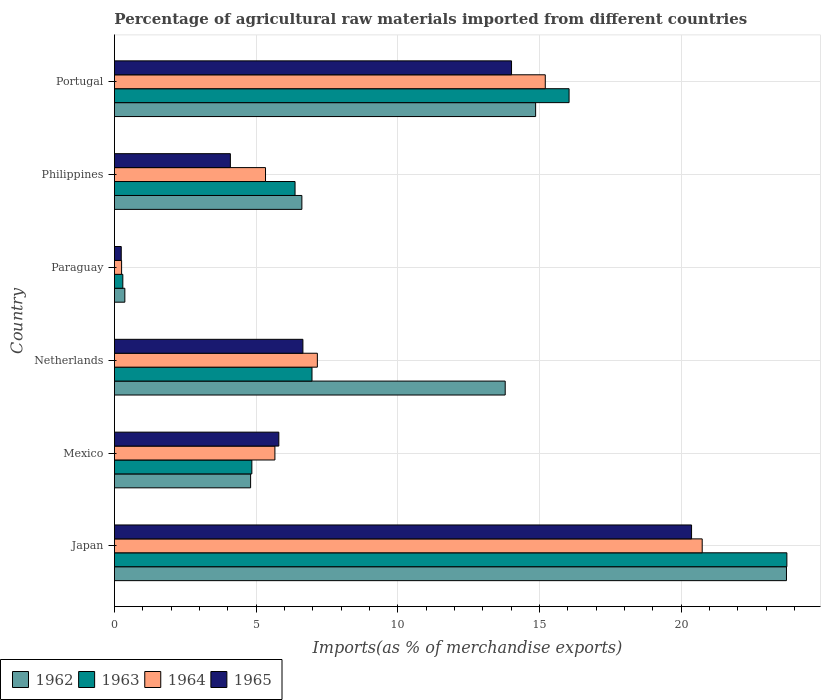How many different coloured bars are there?
Ensure brevity in your answer.  4. Are the number of bars on each tick of the Y-axis equal?
Provide a succinct answer. Yes. How many bars are there on the 5th tick from the bottom?
Make the answer very short. 4. What is the label of the 2nd group of bars from the top?
Offer a terse response. Philippines. What is the percentage of imports to different countries in 1962 in Paraguay?
Give a very brief answer. 0.37. Across all countries, what is the maximum percentage of imports to different countries in 1962?
Give a very brief answer. 23.71. Across all countries, what is the minimum percentage of imports to different countries in 1963?
Your answer should be compact. 0.3. In which country was the percentage of imports to different countries in 1965 minimum?
Your answer should be very brief. Paraguay. What is the total percentage of imports to different countries in 1964 in the graph?
Give a very brief answer. 54.35. What is the difference between the percentage of imports to different countries in 1964 in Japan and that in Portugal?
Your response must be concise. 5.54. What is the difference between the percentage of imports to different countries in 1965 in Japan and the percentage of imports to different countries in 1963 in Netherlands?
Ensure brevity in your answer.  13.39. What is the average percentage of imports to different countries in 1962 per country?
Keep it short and to the point. 10.69. What is the difference between the percentage of imports to different countries in 1965 and percentage of imports to different countries in 1962 in Netherlands?
Provide a short and direct response. -7.14. What is the ratio of the percentage of imports to different countries in 1963 in Netherlands to that in Philippines?
Your response must be concise. 1.09. What is the difference between the highest and the second highest percentage of imports to different countries in 1965?
Provide a short and direct response. 6.35. What is the difference between the highest and the lowest percentage of imports to different countries in 1962?
Offer a terse response. 23.35. In how many countries, is the percentage of imports to different countries in 1963 greater than the average percentage of imports to different countries in 1963 taken over all countries?
Keep it short and to the point. 2. Is the sum of the percentage of imports to different countries in 1962 in Netherlands and Paraguay greater than the maximum percentage of imports to different countries in 1965 across all countries?
Your response must be concise. No. What does the 2nd bar from the top in Philippines represents?
Keep it short and to the point. 1964. What does the 1st bar from the bottom in Philippines represents?
Ensure brevity in your answer.  1962. Are all the bars in the graph horizontal?
Offer a very short reply. Yes. Are the values on the major ticks of X-axis written in scientific E-notation?
Give a very brief answer. No. Does the graph contain any zero values?
Your answer should be compact. No. Does the graph contain grids?
Make the answer very short. Yes. What is the title of the graph?
Provide a succinct answer. Percentage of agricultural raw materials imported from different countries. What is the label or title of the X-axis?
Your response must be concise. Imports(as % of merchandise exports). What is the label or title of the Y-axis?
Keep it short and to the point. Country. What is the Imports(as % of merchandise exports) in 1962 in Japan?
Provide a succinct answer. 23.71. What is the Imports(as % of merchandise exports) in 1963 in Japan?
Keep it short and to the point. 23.73. What is the Imports(as % of merchandise exports) in 1964 in Japan?
Offer a very short reply. 20.74. What is the Imports(as % of merchandise exports) of 1965 in Japan?
Make the answer very short. 20.37. What is the Imports(as % of merchandise exports) in 1962 in Mexico?
Offer a very short reply. 4.81. What is the Imports(as % of merchandise exports) of 1963 in Mexico?
Provide a short and direct response. 4.85. What is the Imports(as % of merchandise exports) in 1964 in Mexico?
Your answer should be very brief. 5.66. What is the Imports(as % of merchandise exports) in 1965 in Mexico?
Your response must be concise. 5.8. What is the Imports(as % of merchandise exports) of 1962 in Netherlands?
Your response must be concise. 13.79. What is the Imports(as % of merchandise exports) in 1963 in Netherlands?
Ensure brevity in your answer.  6.97. What is the Imports(as % of merchandise exports) of 1964 in Netherlands?
Give a very brief answer. 7.16. What is the Imports(as % of merchandise exports) of 1965 in Netherlands?
Give a very brief answer. 6.65. What is the Imports(as % of merchandise exports) in 1962 in Paraguay?
Keep it short and to the point. 0.37. What is the Imports(as % of merchandise exports) in 1963 in Paraguay?
Your response must be concise. 0.3. What is the Imports(as % of merchandise exports) in 1964 in Paraguay?
Your response must be concise. 0.25. What is the Imports(as % of merchandise exports) of 1965 in Paraguay?
Offer a terse response. 0.24. What is the Imports(as % of merchandise exports) of 1962 in Philippines?
Offer a terse response. 6.61. What is the Imports(as % of merchandise exports) in 1963 in Philippines?
Your answer should be compact. 6.37. What is the Imports(as % of merchandise exports) in 1964 in Philippines?
Your answer should be compact. 5.33. What is the Imports(as % of merchandise exports) in 1965 in Philippines?
Make the answer very short. 4.09. What is the Imports(as % of merchandise exports) in 1962 in Portugal?
Ensure brevity in your answer.  14.86. What is the Imports(as % of merchandise exports) in 1963 in Portugal?
Offer a terse response. 16.04. What is the Imports(as % of merchandise exports) of 1964 in Portugal?
Provide a short and direct response. 15.2. What is the Imports(as % of merchandise exports) in 1965 in Portugal?
Your answer should be very brief. 14.01. Across all countries, what is the maximum Imports(as % of merchandise exports) of 1962?
Provide a succinct answer. 23.71. Across all countries, what is the maximum Imports(as % of merchandise exports) of 1963?
Offer a very short reply. 23.73. Across all countries, what is the maximum Imports(as % of merchandise exports) in 1964?
Make the answer very short. 20.74. Across all countries, what is the maximum Imports(as % of merchandise exports) of 1965?
Make the answer very short. 20.37. Across all countries, what is the minimum Imports(as % of merchandise exports) in 1962?
Provide a short and direct response. 0.37. Across all countries, what is the minimum Imports(as % of merchandise exports) in 1963?
Offer a very short reply. 0.3. Across all countries, what is the minimum Imports(as % of merchandise exports) in 1964?
Provide a short and direct response. 0.25. Across all countries, what is the minimum Imports(as % of merchandise exports) of 1965?
Your response must be concise. 0.24. What is the total Imports(as % of merchandise exports) of 1962 in the graph?
Offer a very short reply. 64.16. What is the total Imports(as % of merchandise exports) in 1963 in the graph?
Keep it short and to the point. 58.26. What is the total Imports(as % of merchandise exports) of 1964 in the graph?
Offer a terse response. 54.35. What is the total Imports(as % of merchandise exports) in 1965 in the graph?
Offer a terse response. 51.16. What is the difference between the Imports(as % of merchandise exports) of 1962 in Japan and that in Mexico?
Your answer should be compact. 18.91. What is the difference between the Imports(as % of merchandise exports) in 1963 in Japan and that in Mexico?
Provide a short and direct response. 18.88. What is the difference between the Imports(as % of merchandise exports) in 1964 in Japan and that in Mexico?
Provide a succinct answer. 15.08. What is the difference between the Imports(as % of merchandise exports) of 1965 in Japan and that in Mexico?
Your answer should be compact. 14.56. What is the difference between the Imports(as % of merchandise exports) in 1962 in Japan and that in Netherlands?
Your response must be concise. 9.93. What is the difference between the Imports(as % of merchandise exports) of 1963 in Japan and that in Netherlands?
Offer a terse response. 16.76. What is the difference between the Imports(as % of merchandise exports) of 1964 in Japan and that in Netherlands?
Offer a terse response. 13.58. What is the difference between the Imports(as % of merchandise exports) in 1965 in Japan and that in Netherlands?
Give a very brief answer. 13.72. What is the difference between the Imports(as % of merchandise exports) in 1962 in Japan and that in Paraguay?
Provide a succinct answer. 23.35. What is the difference between the Imports(as % of merchandise exports) of 1963 in Japan and that in Paraguay?
Your answer should be compact. 23.43. What is the difference between the Imports(as % of merchandise exports) of 1964 in Japan and that in Paraguay?
Offer a very short reply. 20.49. What is the difference between the Imports(as % of merchandise exports) in 1965 in Japan and that in Paraguay?
Offer a very short reply. 20.13. What is the difference between the Imports(as % of merchandise exports) in 1962 in Japan and that in Philippines?
Provide a short and direct response. 17.1. What is the difference between the Imports(as % of merchandise exports) of 1963 in Japan and that in Philippines?
Your response must be concise. 17.36. What is the difference between the Imports(as % of merchandise exports) of 1964 in Japan and that in Philippines?
Make the answer very short. 15.41. What is the difference between the Imports(as % of merchandise exports) in 1965 in Japan and that in Philippines?
Provide a short and direct response. 16.27. What is the difference between the Imports(as % of merchandise exports) of 1962 in Japan and that in Portugal?
Provide a succinct answer. 8.85. What is the difference between the Imports(as % of merchandise exports) of 1963 in Japan and that in Portugal?
Provide a succinct answer. 7.69. What is the difference between the Imports(as % of merchandise exports) of 1964 in Japan and that in Portugal?
Provide a short and direct response. 5.54. What is the difference between the Imports(as % of merchandise exports) in 1965 in Japan and that in Portugal?
Your response must be concise. 6.35. What is the difference between the Imports(as % of merchandise exports) in 1962 in Mexico and that in Netherlands?
Offer a very short reply. -8.98. What is the difference between the Imports(as % of merchandise exports) in 1963 in Mexico and that in Netherlands?
Provide a short and direct response. -2.12. What is the difference between the Imports(as % of merchandise exports) of 1964 in Mexico and that in Netherlands?
Provide a succinct answer. -1.5. What is the difference between the Imports(as % of merchandise exports) of 1965 in Mexico and that in Netherlands?
Keep it short and to the point. -0.85. What is the difference between the Imports(as % of merchandise exports) in 1962 in Mexico and that in Paraguay?
Provide a short and direct response. 4.44. What is the difference between the Imports(as % of merchandise exports) in 1963 in Mexico and that in Paraguay?
Offer a terse response. 4.55. What is the difference between the Imports(as % of merchandise exports) of 1964 in Mexico and that in Paraguay?
Ensure brevity in your answer.  5.41. What is the difference between the Imports(as % of merchandise exports) in 1965 in Mexico and that in Paraguay?
Provide a short and direct response. 5.56. What is the difference between the Imports(as % of merchandise exports) of 1962 in Mexico and that in Philippines?
Your answer should be very brief. -1.81. What is the difference between the Imports(as % of merchandise exports) of 1963 in Mexico and that in Philippines?
Give a very brief answer. -1.52. What is the difference between the Imports(as % of merchandise exports) of 1964 in Mexico and that in Philippines?
Your answer should be very brief. 0.33. What is the difference between the Imports(as % of merchandise exports) in 1965 in Mexico and that in Philippines?
Make the answer very short. 1.71. What is the difference between the Imports(as % of merchandise exports) in 1962 in Mexico and that in Portugal?
Make the answer very short. -10.06. What is the difference between the Imports(as % of merchandise exports) of 1963 in Mexico and that in Portugal?
Your answer should be very brief. -11.19. What is the difference between the Imports(as % of merchandise exports) in 1964 in Mexico and that in Portugal?
Keep it short and to the point. -9.54. What is the difference between the Imports(as % of merchandise exports) of 1965 in Mexico and that in Portugal?
Offer a very short reply. -8.21. What is the difference between the Imports(as % of merchandise exports) in 1962 in Netherlands and that in Paraguay?
Make the answer very short. 13.42. What is the difference between the Imports(as % of merchandise exports) of 1963 in Netherlands and that in Paraguay?
Give a very brief answer. 6.68. What is the difference between the Imports(as % of merchandise exports) in 1964 in Netherlands and that in Paraguay?
Your answer should be compact. 6.91. What is the difference between the Imports(as % of merchandise exports) in 1965 in Netherlands and that in Paraguay?
Your answer should be very brief. 6.41. What is the difference between the Imports(as % of merchandise exports) of 1962 in Netherlands and that in Philippines?
Your response must be concise. 7.18. What is the difference between the Imports(as % of merchandise exports) of 1963 in Netherlands and that in Philippines?
Provide a short and direct response. 0.6. What is the difference between the Imports(as % of merchandise exports) of 1964 in Netherlands and that in Philippines?
Your answer should be compact. 1.83. What is the difference between the Imports(as % of merchandise exports) in 1965 in Netherlands and that in Philippines?
Ensure brevity in your answer.  2.56. What is the difference between the Imports(as % of merchandise exports) in 1962 in Netherlands and that in Portugal?
Offer a terse response. -1.07. What is the difference between the Imports(as % of merchandise exports) in 1963 in Netherlands and that in Portugal?
Offer a very short reply. -9.07. What is the difference between the Imports(as % of merchandise exports) in 1964 in Netherlands and that in Portugal?
Provide a succinct answer. -8.04. What is the difference between the Imports(as % of merchandise exports) in 1965 in Netherlands and that in Portugal?
Make the answer very short. -7.36. What is the difference between the Imports(as % of merchandise exports) in 1962 in Paraguay and that in Philippines?
Provide a short and direct response. -6.25. What is the difference between the Imports(as % of merchandise exports) of 1963 in Paraguay and that in Philippines?
Your response must be concise. -6.08. What is the difference between the Imports(as % of merchandise exports) of 1964 in Paraguay and that in Philippines?
Ensure brevity in your answer.  -5.08. What is the difference between the Imports(as % of merchandise exports) in 1965 in Paraguay and that in Philippines?
Your answer should be compact. -3.85. What is the difference between the Imports(as % of merchandise exports) of 1962 in Paraguay and that in Portugal?
Offer a terse response. -14.5. What is the difference between the Imports(as % of merchandise exports) in 1963 in Paraguay and that in Portugal?
Provide a succinct answer. -15.75. What is the difference between the Imports(as % of merchandise exports) of 1964 in Paraguay and that in Portugal?
Provide a short and direct response. -14.95. What is the difference between the Imports(as % of merchandise exports) in 1965 in Paraguay and that in Portugal?
Provide a succinct answer. -13.77. What is the difference between the Imports(as % of merchandise exports) of 1962 in Philippines and that in Portugal?
Offer a terse response. -8.25. What is the difference between the Imports(as % of merchandise exports) of 1963 in Philippines and that in Portugal?
Your answer should be very brief. -9.67. What is the difference between the Imports(as % of merchandise exports) in 1964 in Philippines and that in Portugal?
Provide a succinct answer. -9.87. What is the difference between the Imports(as % of merchandise exports) in 1965 in Philippines and that in Portugal?
Your answer should be compact. -9.92. What is the difference between the Imports(as % of merchandise exports) in 1962 in Japan and the Imports(as % of merchandise exports) in 1963 in Mexico?
Keep it short and to the point. 18.87. What is the difference between the Imports(as % of merchandise exports) of 1962 in Japan and the Imports(as % of merchandise exports) of 1964 in Mexico?
Give a very brief answer. 18.05. What is the difference between the Imports(as % of merchandise exports) in 1962 in Japan and the Imports(as % of merchandise exports) in 1965 in Mexico?
Provide a short and direct response. 17.91. What is the difference between the Imports(as % of merchandise exports) in 1963 in Japan and the Imports(as % of merchandise exports) in 1964 in Mexico?
Make the answer very short. 18.07. What is the difference between the Imports(as % of merchandise exports) of 1963 in Japan and the Imports(as % of merchandise exports) of 1965 in Mexico?
Provide a succinct answer. 17.93. What is the difference between the Imports(as % of merchandise exports) of 1964 in Japan and the Imports(as % of merchandise exports) of 1965 in Mexico?
Your response must be concise. 14.94. What is the difference between the Imports(as % of merchandise exports) in 1962 in Japan and the Imports(as % of merchandise exports) in 1963 in Netherlands?
Make the answer very short. 16.74. What is the difference between the Imports(as % of merchandise exports) of 1962 in Japan and the Imports(as % of merchandise exports) of 1964 in Netherlands?
Offer a very short reply. 16.55. What is the difference between the Imports(as % of merchandise exports) of 1962 in Japan and the Imports(as % of merchandise exports) of 1965 in Netherlands?
Offer a terse response. 17.06. What is the difference between the Imports(as % of merchandise exports) in 1963 in Japan and the Imports(as % of merchandise exports) in 1964 in Netherlands?
Ensure brevity in your answer.  16.57. What is the difference between the Imports(as % of merchandise exports) in 1963 in Japan and the Imports(as % of merchandise exports) in 1965 in Netherlands?
Your answer should be very brief. 17.08. What is the difference between the Imports(as % of merchandise exports) in 1964 in Japan and the Imports(as % of merchandise exports) in 1965 in Netherlands?
Your response must be concise. 14.09. What is the difference between the Imports(as % of merchandise exports) of 1962 in Japan and the Imports(as % of merchandise exports) of 1963 in Paraguay?
Give a very brief answer. 23.42. What is the difference between the Imports(as % of merchandise exports) in 1962 in Japan and the Imports(as % of merchandise exports) in 1964 in Paraguay?
Provide a succinct answer. 23.46. What is the difference between the Imports(as % of merchandise exports) of 1962 in Japan and the Imports(as % of merchandise exports) of 1965 in Paraguay?
Your answer should be compact. 23.47. What is the difference between the Imports(as % of merchandise exports) in 1963 in Japan and the Imports(as % of merchandise exports) in 1964 in Paraguay?
Provide a short and direct response. 23.48. What is the difference between the Imports(as % of merchandise exports) in 1963 in Japan and the Imports(as % of merchandise exports) in 1965 in Paraguay?
Your answer should be compact. 23.49. What is the difference between the Imports(as % of merchandise exports) in 1964 in Japan and the Imports(as % of merchandise exports) in 1965 in Paraguay?
Give a very brief answer. 20.5. What is the difference between the Imports(as % of merchandise exports) in 1962 in Japan and the Imports(as % of merchandise exports) in 1963 in Philippines?
Your answer should be very brief. 17.34. What is the difference between the Imports(as % of merchandise exports) of 1962 in Japan and the Imports(as % of merchandise exports) of 1964 in Philippines?
Your response must be concise. 18.38. What is the difference between the Imports(as % of merchandise exports) in 1962 in Japan and the Imports(as % of merchandise exports) in 1965 in Philippines?
Your answer should be compact. 19.62. What is the difference between the Imports(as % of merchandise exports) in 1963 in Japan and the Imports(as % of merchandise exports) in 1964 in Philippines?
Provide a succinct answer. 18.4. What is the difference between the Imports(as % of merchandise exports) in 1963 in Japan and the Imports(as % of merchandise exports) in 1965 in Philippines?
Provide a succinct answer. 19.64. What is the difference between the Imports(as % of merchandise exports) of 1964 in Japan and the Imports(as % of merchandise exports) of 1965 in Philippines?
Make the answer very short. 16.65. What is the difference between the Imports(as % of merchandise exports) of 1962 in Japan and the Imports(as % of merchandise exports) of 1963 in Portugal?
Ensure brevity in your answer.  7.67. What is the difference between the Imports(as % of merchandise exports) in 1962 in Japan and the Imports(as % of merchandise exports) in 1964 in Portugal?
Offer a very short reply. 8.51. What is the difference between the Imports(as % of merchandise exports) in 1962 in Japan and the Imports(as % of merchandise exports) in 1965 in Portugal?
Your answer should be very brief. 9.7. What is the difference between the Imports(as % of merchandise exports) of 1963 in Japan and the Imports(as % of merchandise exports) of 1964 in Portugal?
Make the answer very short. 8.53. What is the difference between the Imports(as % of merchandise exports) of 1963 in Japan and the Imports(as % of merchandise exports) of 1965 in Portugal?
Offer a very short reply. 9.72. What is the difference between the Imports(as % of merchandise exports) of 1964 in Japan and the Imports(as % of merchandise exports) of 1965 in Portugal?
Offer a very short reply. 6.73. What is the difference between the Imports(as % of merchandise exports) in 1962 in Mexico and the Imports(as % of merchandise exports) in 1963 in Netherlands?
Your answer should be very brief. -2.17. What is the difference between the Imports(as % of merchandise exports) in 1962 in Mexico and the Imports(as % of merchandise exports) in 1964 in Netherlands?
Give a very brief answer. -2.36. What is the difference between the Imports(as % of merchandise exports) of 1962 in Mexico and the Imports(as % of merchandise exports) of 1965 in Netherlands?
Your answer should be compact. -1.85. What is the difference between the Imports(as % of merchandise exports) in 1963 in Mexico and the Imports(as % of merchandise exports) in 1964 in Netherlands?
Your answer should be compact. -2.31. What is the difference between the Imports(as % of merchandise exports) in 1963 in Mexico and the Imports(as % of merchandise exports) in 1965 in Netherlands?
Offer a terse response. -1.8. What is the difference between the Imports(as % of merchandise exports) of 1964 in Mexico and the Imports(as % of merchandise exports) of 1965 in Netherlands?
Your response must be concise. -0.99. What is the difference between the Imports(as % of merchandise exports) in 1962 in Mexico and the Imports(as % of merchandise exports) in 1963 in Paraguay?
Keep it short and to the point. 4.51. What is the difference between the Imports(as % of merchandise exports) in 1962 in Mexico and the Imports(as % of merchandise exports) in 1964 in Paraguay?
Offer a very short reply. 4.55. What is the difference between the Imports(as % of merchandise exports) of 1962 in Mexico and the Imports(as % of merchandise exports) of 1965 in Paraguay?
Make the answer very short. 4.57. What is the difference between the Imports(as % of merchandise exports) in 1963 in Mexico and the Imports(as % of merchandise exports) in 1964 in Paraguay?
Make the answer very short. 4.6. What is the difference between the Imports(as % of merchandise exports) of 1963 in Mexico and the Imports(as % of merchandise exports) of 1965 in Paraguay?
Your answer should be compact. 4.61. What is the difference between the Imports(as % of merchandise exports) of 1964 in Mexico and the Imports(as % of merchandise exports) of 1965 in Paraguay?
Your answer should be compact. 5.42. What is the difference between the Imports(as % of merchandise exports) of 1962 in Mexico and the Imports(as % of merchandise exports) of 1963 in Philippines?
Provide a short and direct response. -1.57. What is the difference between the Imports(as % of merchandise exports) of 1962 in Mexico and the Imports(as % of merchandise exports) of 1964 in Philippines?
Provide a succinct answer. -0.53. What is the difference between the Imports(as % of merchandise exports) in 1962 in Mexico and the Imports(as % of merchandise exports) in 1965 in Philippines?
Give a very brief answer. 0.71. What is the difference between the Imports(as % of merchandise exports) in 1963 in Mexico and the Imports(as % of merchandise exports) in 1964 in Philippines?
Your answer should be compact. -0.48. What is the difference between the Imports(as % of merchandise exports) of 1963 in Mexico and the Imports(as % of merchandise exports) of 1965 in Philippines?
Your response must be concise. 0.76. What is the difference between the Imports(as % of merchandise exports) of 1964 in Mexico and the Imports(as % of merchandise exports) of 1965 in Philippines?
Provide a short and direct response. 1.57. What is the difference between the Imports(as % of merchandise exports) in 1962 in Mexico and the Imports(as % of merchandise exports) in 1963 in Portugal?
Your answer should be compact. -11.24. What is the difference between the Imports(as % of merchandise exports) in 1962 in Mexico and the Imports(as % of merchandise exports) in 1964 in Portugal?
Ensure brevity in your answer.  -10.4. What is the difference between the Imports(as % of merchandise exports) of 1962 in Mexico and the Imports(as % of merchandise exports) of 1965 in Portugal?
Provide a short and direct response. -9.21. What is the difference between the Imports(as % of merchandise exports) of 1963 in Mexico and the Imports(as % of merchandise exports) of 1964 in Portugal?
Your answer should be compact. -10.35. What is the difference between the Imports(as % of merchandise exports) in 1963 in Mexico and the Imports(as % of merchandise exports) in 1965 in Portugal?
Ensure brevity in your answer.  -9.16. What is the difference between the Imports(as % of merchandise exports) of 1964 in Mexico and the Imports(as % of merchandise exports) of 1965 in Portugal?
Provide a succinct answer. -8.35. What is the difference between the Imports(as % of merchandise exports) in 1962 in Netherlands and the Imports(as % of merchandise exports) in 1963 in Paraguay?
Offer a very short reply. 13.49. What is the difference between the Imports(as % of merchandise exports) in 1962 in Netherlands and the Imports(as % of merchandise exports) in 1964 in Paraguay?
Your response must be concise. 13.54. What is the difference between the Imports(as % of merchandise exports) in 1962 in Netherlands and the Imports(as % of merchandise exports) in 1965 in Paraguay?
Offer a terse response. 13.55. What is the difference between the Imports(as % of merchandise exports) in 1963 in Netherlands and the Imports(as % of merchandise exports) in 1964 in Paraguay?
Give a very brief answer. 6.72. What is the difference between the Imports(as % of merchandise exports) of 1963 in Netherlands and the Imports(as % of merchandise exports) of 1965 in Paraguay?
Offer a very short reply. 6.73. What is the difference between the Imports(as % of merchandise exports) in 1964 in Netherlands and the Imports(as % of merchandise exports) in 1965 in Paraguay?
Ensure brevity in your answer.  6.92. What is the difference between the Imports(as % of merchandise exports) in 1962 in Netherlands and the Imports(as % of merchandise exports) in 1963 in Philippines?
Make the answer very short. 7.42. What is the difference between the Imports(as % of merchandise exports) of 1962 in Netherlands and the Imports(as % of merchandise exports) of 1964 in Philippines?
Keep it short and to the point. 8.46. What is the difference between the Imports(as % of merchandise exports) in 1962 in Netherlands and the Imports(as % of merchandise exports) in 1965 in Philippines?
Ensure brevity in your answer.  9.7. What is the difference between the Imports(as % of merchandise exports) in 1963 in Netherlands and the Imports(as % of merchandise exports) in 1964 in Philippines?
Your answer should be very brief. 1.64. What is the difference between the Imports(as % of merchandise exports) of 1963 in Netherlands and the Imports(as % of merchandise exports) of 1965 in Philippines?
Your answer should be very brief. 2.88. What is the difference between the Imports(as % of merchandise exports) in 1964 in Netherlands and the Imports(as % of merchandise exports) in 1965 in Philippines?
Offer a terse response. 3.07. What is the difference between the Imports(as % of merchandise exports) in 1962 in Netherlands and the Imports(as % of merchandise exports) in 1963 in Portugal?
Make the answer very short. -2.25. What is the difference between the Imports(as % of merchandise exports) in 1962 in Netherlands and the Imports(as % of merchandise exports) in 1964 in Portugal?
Your answer should be very brief. -1.41. What is the difference between the Imports(as % of merchandise exports) of 1962 in Netherlands and the Imports(as % of merchandise exports) of 1965 in Portugal?
Provide a succinct answer. -0.22. What is the difference between the Imports(as % of merchandise exports) in 1963 in Netherlands and the Imports(as % of merchandise exports) in 1964 in Portugal?
Keep it short and to the point. -8.23. What is the difference between the Imports(as % of merchandise exports) of 1963 in Netherlands and the Imports(as % of merchandise exports) of 1965 in Portugal?
Your answer should be very brief. -7.04. What is the difference between the Imports(as % of merchandise exports) of 1964 in Netherlands and the Imports(as % of merchandise exports) of 1965 in Portugal?
Provide a short and direct response. -6.85. What is the difference between the Imports(as % of merchandise exports) in 1962 in Paraguay and the Imports(as % of merchandise exports) in 1963 in Philippines?
Ensure brevity in your answer.  -6.01. What is the difference between the Imports(as % of merchandise exports) of 1962 in Paraguay and the Imports(as % of merchandise exports) of 1964 in Philippines?
Offer a terse response. -4.96. What is the difference between the Imports(as % of merchandise exports) of 1962 in Paraguay and the Imports(as % of merchandise exports) of 1965 in Philippines?
Provide a succinct answer. -3.72. What is the difference between the Imports(as % of merchandise exports) in 1963 in Paraguay and the Imports(as % of merchandise exports) in 1964 in Philippines?
Provide a succinct answer. -5.04. What is the difference between the Imports(as % of merchandise exports) in 1963 in Paraguay and the Imports(as % of merchandise exports) in 1965 in Philippines?
Offer a very short reply. -3.8. What is the difference between the Imports(as % of merchandise exports) in 1964 in Paraguay and the Imports(as % of merchandise exports) in 1965 in Philippines?
Make the answer very short. -3.84. What is the difference between the Imports(as % of merchandise exports) of 1962 in Paraguay and the Imports(as % of merchandise exports) of 1963 in Portugal?
Provide a succinct answer. -15.68. What is the difference between the Imports(as % of merchandise exports) of 1962 in Paraguay and the Imports(as % of merchandise exports) of 1964 in Portugal?
Your answer should be very brief. -14.84. What is the difference between the Imports(as % of merchandise exports) in 1962 in Paraguay and the Imports(as % of merchandise exports) in 1965 in Portugal?
Your answer should be very brief. -13.65. What is the difference between the Imports(as % of merchandise exports) in 1963 in Paraguay and the Imports(as % of merchandise exports) in 1964 in Portugal?
Ensure brevity in your answer.  -14.91. What is the difference between the Imports(as % of merchandise exports) of 1963 in Paraguay and the Imports(as % of merchandise exports) of 1965 in Portugal?
Offer a terse response. -13.72. What is the difference between the Imports(as % of merchandise exports) of 1964 in Paraguay and the Imports(as % of merchandise exports) of 1965 in Portugal?
Give a very brief answer. -13.76. What is the difference between the Imports(as % of merchandise exports) in 1962 in Philippines and the Imports(as % of merchandise exports) in 1963 in Portugal?
Provide a succinct answer. -9.43. What is the difference between the Imports(as % of merchandise exports) in 1962 in Philippines and the Imports(as % of merchandise exports) in 1964 in Portugal?
Your response must be concise. -8.59. What is the difference between the Imports(as % of merchandise exports) of 1962 in Philippines and the Imports(as % of merchandise exports) of 1965 in Portugal?
Keep it short and to the point. -7.4. What is the difference between the Imports(as % of merchandise exports) in 1963 in Philippines and the Imports(as % of merchandise exports) in 1964 in Portugal?
Your answer should be compact. -8.83. What is the difference between the Imports(as % of merchandise exports) in 1963 in Philippines and the Imports(as % of merchandise exports) in 1965 in Portugal?
Your answer should be compact. -7.64. What is the difference between the Imports(as % of merchandise exports) in 1964 in Philippines and the Imports(as % of merchandise exports) in 1965 in Portugal?
Your response must be concise. -8.68. What is the average Imports(as % of merchandise exports) in 1962 per country?
Provide a succinct answer. 10.69. What is the average Imports(as % of merchandise exports) of 1963 per country?
Provide a short and direct response. 9.71. What is the average Imports(as % of merchandise exports) in 1964 per country?
Provide a short and direct response. 9.06. What is the average Imports(as % of merchandise exports) in 1965 per country?
Give a very brief answer. 8.53. What is the difference between the Imports(as % of merchandise exports) in 1962 and Imports(as % of merchandise exports) in 1963 in Japan?
Your response must be concise. -0.01. What is the difference between the Imports(as % of merchandise exports) of 1962 and Imports(as % of merchandise exports) of 1964 in Japan?
Provide a short and direct response. 2.97. What is the difference between the Imports(as % of merchandise exports) of 1962 and Imports(as % of merchandise exports) of 1965 in Japan?
Your answer should be very brief. 3.35. What is the difference between the Imports(as % of merchandise exports) in 1963 and Imports(as % of merchandise exports) in 1964 in Japan?
Your response must be concise. 2.99. What is the difference between the Imports(as % of merchandise exports) of 1963 and Imports(as % of merchandise exports) of 1965 in Japan?
Your answer should be compact. 3.36. What is the difference between the Imports(as % of merchandise exports) in 1964 and Imports(as % of merchandise exports) in 1965 in Japan?
Offer a terse response. 0.38. What is the difference between the Imports(as % of merchandise exports) of 1962 and Imports(as % of merchandise exports) of 1963 in Mexico?
Keep it short and to the point. -0.04. What is the difference between the Imports(as % of merchandise exports) in 1962 and Imports(as % of merchandise exports) in 1964 in Mexico?
Provide a succinct answer. -0.86. What is the difference between the Imports(as % of merchandise exports) of 1962 and Imports(as % of merchandise exports) of 1965 in Mexico?
Your answer should be compact. -1. What is the difference between the Imports(as % of merchandise exports) in 1963 and Imports(as % of merchandise exports) in 1964 in Mexico?
Offer a terse response. -0.81. What is the difference between the Imports(as % of merchandise exports) in 1963 and Imports(as % of merchandise exports) in 1965 in Mexico?
Provide a succinct answer. -0.95. What is the difference between the Imports(as % of merchandise exports) of 1964 and Imports(as % of merchandise exports) of 1965 in Mexico?
Ensure brevity in your answer.  -0.14. What is the difference between the Imports(as % of merchandise exports) in 1962 and Imports(as % of merchandise exports) in 1963 in Netherlands?
Make the answer very short. 6.82. What is the difference between the Imports(as % of merchandise exports) of 1962 and Imports(as % of merchandise exports) of 1964 in Netherlands?
Offer a very short reply. 6.63. What is the difference between the Imports(as % of merchandise exports) of 1962 and Imports(as % of merchandise exports) of 1965 in Netherlands?
Make the answer very short. 7.14. What is the difference between the Imports(as % of merchandise exports) in 1963 and Imports(as % of merchandise exports) in 1964 in Netherlands?
Your response must be concise. -0.19. What is the difference between the Imports(as % of merchandise exports) in 1963 and Imports(as % of merchandise exports) in 1965 in Netherlands?
Your answer should be compact. 0.32. What is the difference between the Imports(as % of merchandise exports) of 1964 and Imports(as % of merchandise exports) of 1965 in Netherlands?
Your answer should be compact. 0.51. What is the difference between the Imports(as % of merchandise exports) in 1962 and Imports(as % of merchandise exports) in 1963 in Paraguay?
Your answer should be very brief. 0.07. What is the difference between the Imports(as % of merchandise exports) of 1962 and Imports(as % of merchandise exports) of 1964 in Paraguay?
Keep it short and to the point. 0.11. What is the difference between the Imports(as % of merchandise exports) in 1962 and Imports(as % of merchandise exports) in 1965 in Paraguay?
Give a very brief answer. 0.13. What is the difference between the Imports(as % of merchandise exports) of 1963 and Imports(as % of merchandise exports) of 1964 in Paraguay?
Ensure brevity in your answer.  0.04. What is the difference between the Imports(as % of merchandise exports) of 1963 and Imports(as % of merchandise exports) of 1965 in Paraguay?
Keep it short and to the point. 0.06. What is the difference between the Imports(as % of merchandise exports) in 1964 and Imports(as % of merchandise exports) in 1965 in Paraguay?
Offer a very short reply. 0.01. What is the difference between the Imports(as % of merchandise exports) in 1962 and Imports(as % of merchandise exports) in 1963 in Philippines?
Give a very brief answer. 0.24. What is the difference between the Imports(as % of merchandise exports) of 1962 and Imports(as % of merchandise exports) of 1964 in Philippines?
Offer a terse response. 1.28. What is the difference between the Imports(as % of merchandise exports) of 1962 and Imports(as % of merchandise exports) of 1965 in Philippines?
Keep it short and to the point. 2.52. What is the difference between the Imports(as % of merchandise exports) of 1963 and Imports(as % of merchandise exports) of 1964 in Philippines?
Ensure brevity in your answer.  1.04. What is the difference between the Imports(as % of merchandise exports) in 1963 and Imports(as % of merchandise exports) in 1965 in Philippines?
Offer a very short reply. 2.28. What is the difference between the Imports(as % of merchandise exports) in 1964 and Imports(as % of merchandise exports) in 1965 in Philippines?
Your response must be concise. 1.24. What is the difference between the Imports(as % of merchandise exports) of 1962 and Imports(as % of merchandise exports) of 1963 in Portugal?
Your answer should be compact. -1.18. What is the difference between the Imports(as % of merchandise exports) in 1962 and Imports(as % of merchandise exports) in 1964 in Portugal?
Your answer should be compact. -0.34. What is the difference between the Imports(as % of merchandise exports) in 1962 and Imports(as % of merchandise exports) in 1965 in Portugal?
Provide a short and direct response. 0.85. What is the difference between the Imports(as % of merchandise exports) of 1963 and Imports(as % of merchandise exports) of 1964 in Portugal?
Give a very brief answer. 0.84. What is the difference between the Imports(as % of merchandise exports) in 1963 and Imports(as % of merchandise exports) in 1965 in Portugal?
Keep it short and to the point. 2.03. What is the difference between the Imports(as % of merchandise exports) in 1964 and Imports(as % of merchandise exports) in 1965 in Portugal?
Keep it short and to the point. 1.19. What is the ratio of the Imports(as % of merchandise exports) of 1962 in Japan to that in Mexico?
Ensure brevity in your answer.  4.93. What is the ratio of the Imports(as % of merchandise exports) of 1963 in Japan to that in Mexico?
Give a very brief answer. 4.89. What is the ratio of the Imports(as % of merchandise exports) of 1964 in Japan to that in Mexico?
Your answer should be very brief. 3.66. What is the ratio of the Imports(as % of merchandise exports) in 1965 in Japan to that in Mexico?
Keep it short and to the point. 3.51. What is the ratio of the Imports(as % of merchandise exports) in 1962 in Japan to that in Netherlands?
Your answer should be compact. 1.72. What is the ratio of the Imports(as % of merchandise exports) in 1963 in Japan to that in Netherlands?
Your response must be concise. 3.4. What is the ratio of the Imports(as % of merchandise exports) of 1964 in Japan to that in Netherlands?
Make the answer very short. 2.9. What is the ratio of the Imports(as % of merchandise exports) in 1965 in Japan to that in Netherlands?
Offer a terse response. 3.06. What is the ratio of the Imports(as % of merchandise exports) in 1962 in Japan to that in Paraguay?
Offer a very short reply. 64.56. What is the ratio of the Imports(as % of merchandise exports) of 1963 in Japan to that in Paraguay?
Offer a very short reply. 80.13. What is the ratio of the Imports(as % of merchandise exports) of 1964 in Japan to that in Paraguay?
Ensure brevity in your answer.  82.04. What is the ratio of the Imports(as % of merchandise exports) of 1965 in Japan to that in Paraguay?
Your response must be concise. 84.69. What is the ratio of the Imports(as % of merchandise exports) of 1962 in Japan to that in Philippines?
Keep it short and to the point. 3.59. What is the ratio of the Imports(as % of merchandise exports) in 1963 in Japan to that in Philippines?
Provide a succinct answer. 3.72. What is the ratio of the Imports(as % of merchandise exports) in 1964 in Japan to that in Philippines?
Keep it short and to the point. 3.89. What is the ratio of the Imports(as % of merchandise exports) of 1965 in Japan to that in Philippines?
Keep it short and to the point. 4.98. What is the ratio of the Imports(as % of merchandise exports) in 1962 in Japan to that in Portugal?
Provide a succinct answer. 1.6. What is the ratio of the Imports(as % of merchandise exports) of 1963 in Japan to that in Portugal?
Your answer should be compact. 1.48. What is the ratio of the Imports(as % of merchandise exports) of 1964 in Japan to that in Portugal?
Offer a very short reply. 1.36. What is the ratio of the Imports(as % of merchandise exports) in 1965 in Japan to that in Portugal?
Keep it short and to the point. 1.45. What is the ratio of the Imports(as % of merchandise exports) of 1962 in Mexico to that in Netherlands?
Your answer should be very brief. 0.35. What is the ratio of the Imports(as % of merchandise exports) in 1963 in Mexico to that in Netherlands?
Keep it short and to the point. 0.7. What is the ratio of the Imports(as % of merchandise exports) in 1964 in Mexico to that in Netherlands?
Offer a very short reply. 0.79. What is the ratio of the Imports(as % of merchandise exports) in 1965 in Mexico to that in Netherlands?
Your answer should be very brief. 0.87. What is the ratio of the Imports(as % of merchandise exports) in 1962 in Mexico to that in Paraguay?
Make the answer very short. 13.08. What is the ratio of the Imports(as % of merchandise exports) in 1963 in Mexico to that in Paraguay?
Keep it short and to the point. 16.38. What is the ratio of the Imports(as % of merchandise exports) of 1964 in Mexico to that in Paraguay?
Give a very brief answer. 22.4. What is the ratio of the Imports(as % of merchandise exports) in 1965 in Mexico to that in Paraguay?
Ensure brevity in your answer.  24.12. What is the ratio of the Imports(as % of merchandise exports) of 1962 in Mexico to that in Philippines?
Your answer should be very brief. 0.73. What is the ratio of the Imports(as % of merchandise exports) of 1963 in Mexico to that in Philippines?
Provide a succinct answer. 0.76. What is the ratio of the Imports(as % of merchandise exports) of 1964 in Mexico to that in Philippines?
Keep it short and to the point. 1.06. What is the ratio of the Imports(as % of merchandise exports) of 1965 in Mexico to that in Philippines?
Offer a terse response. 1.42. What is the ratio of the Imports(as % of merchandise exports) in 1962 in Mexico to that in Portugal?
Offer a very short reply. 0.32. What is the ratio of the Imports(as % of merchandise exports) of 1963 in Mexico to that in Portugal?
Your answer should be compact. 0.3. What is the ratio of the Imports(as % of merchandise exports) in 1964 in Mexico to that in Portugal?
Offer a terse response. 0.37. What is the ratio of the Imports(as % of merchandise exports) of 1965 in Mexico to that in Portugal?
Give a very brief answer. 0.41. What is the ratio of the Imports(as % of merchandise exports) in 1962 in Netherlands to that in Paraguay?
Your answer should be very brief. 37.54. What is the ratio of the Imports(as % of merchandise exports) of 1963 in Netherlands to that in Paraguay?
Ensure brevity in your answer.  23.54. What is the ratio of the Imports(as % of merchandise exports) in 1964 in Netherlands to that in Paraguay?
Give a very brief answer. 28.32. What is the ratio of the Imports(as % of merchandise exports) in 1965 in Netherlands to that in Paraguay?
Provide a short and direct response. 27.66. What is the ratio of the Imports(as % of merchandise exports) in 1962 in Netherlands to that in Philippines?
Give a very brief answer. 2.08. What is the ratio of the Imports(as % of merchandise exports) in 1963 in Netherlands to that in Philippines?
Provide a succinct answer. 1.09. What is the ratio of the Imports(as % of merchandise exports) of 1964 in Netherlands to that in Philippines?
Your answer should be compact. 1.34. What is the ratio of the Imports(as % of merchandise exports) in 1965 in Netherlands to that in Philippines?
Make the answer very short. 1.63. What is the ratio of the Imports(as % of merchandise exports) in 1962 in Netherlands to that in Portugal?
Provide a short and direct response. 0.93. What is the ratio of the Imports(as % of merchandise exports) in 1963 in Netherlands to that in Portugal?
Your answer should be compact. 0.43. What is the ratio of the Imports(as % of merchandise exports) of 1964 in Netherlands to that in Portugal?
Your answer should be very brief. 0.47. What is the ratio of the Imports(as % of merchandise exports) in 1965 in Netherlands to that in Portugal?
Provide a short and direct response. 0.47. What is the ratio of the Imports(as % of merchandise exports) of 1962 in Paraguay to that in Philippines?
Offer a very short reply. 0.06. What is the ratio of the Imports(as % of merchandise exports) of 1963 in Paraguay to that in Philippines?
Make the answer very short. 0.05. What is the ratio of the Imports(as % of merchandise exports) of 1964 in Paraguay to that in Philippines?
Keep it short and to the point. 0.05. What is the ratio of the Imports(as % of merchandise exports) of 1965 in Paraguay to that in Philippines?
Keep it short and to the point. 0.06. What is the ratio of the Imports(as % of merchandise exports) in 1962 in Paraguay to that in Portugal?
Give a very brief answer. 0.02. What is the ratio of the Imports(as % of merchandise exports) in 1963 in Paraguay to that in Portugal?
Provide a succinct answer. 0.02. What is the ratio of the Imports(as % of merchandise exports) of 1964 in Paraguay to that in Portugal?
Your answer should be compact. 0.02. What is the ratio of the Imports(as % of merchandise exports) of 1965 in Paraguay to that in Portugal?
Give a very brief answer. 0.02. What is the ratio of the Imports(as % of merchandise exports) in 1962 in Philippines to that in Portugal?
Offer a very short reply. 0.45. What is the ratio of the Imports(as % of merchandise exports) of 1963 in Philippines to that in Portugal?
Offer a terse response. 0.4. What is the ratio of the Imports(as % of merchandise exports) of 1964 in Philippines to that in Portugal?
Your response must be concise. 0.35. What is the ratio of the Imports(as % of merchandise exports) in 1965 in Philippines to that in Portugal?
Keep it short and to the point. 0.29. What is the difference between the highest and the second highest Imports(as % of merchandise exports) of 1962?
Provide a short and direct response. 8.85. What is the difference between the highest and the second highest Imports(as % of merchandise exports) of 1963?
Give a very brief answer. 7.69. What is the difference between the highest and the second highest Imports(as % of merchandise exports) of 1964?
Your answer should be compact. 5.54. What is the difference between the highest and the second highest Imports(as % of merchandise exports) in 1965?
Make the answer very short. 6.35. What is the difference between the highest and the lowest Imports(as % of merchandise exports) in 1962?
Offer a very short reply. 23.35. What is the difference between the highest and the lowest Imports(as % of merchandise exports) in 1963?
Your answer should be compact. 23.43. What is the difference between the highest and the lowest Imports(as % of merchandise exports) of 1964?
Your answer should be compact. 20.49. What is the difference between the highest and the lowest Imports(as % of merchandise exports) of 1965?
Offer a very short reply. 20.13. 